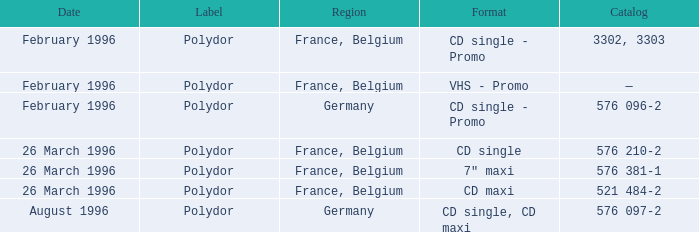Name the region with catalog of 576 097-2 Germany. 